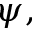<formula> <loc_0><loc_0><loc_500><loc_500>\psi ,</formula> 